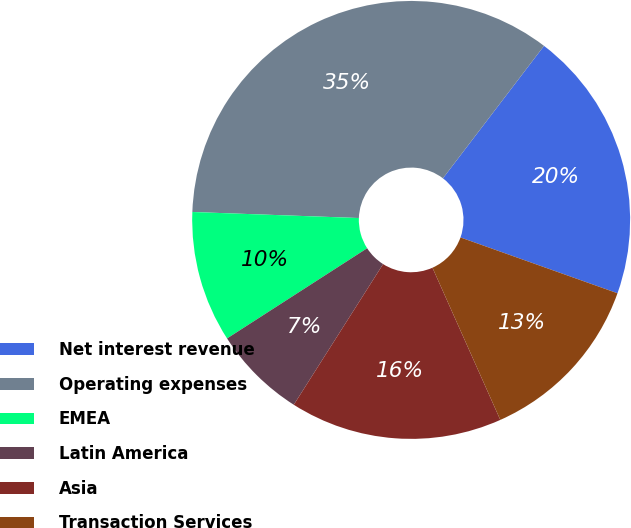Convert chart to OTSL. <chart><loc_0><loc_0><loc_500><loc_500><pie_chart><fcel>Net interest revenue<fcel>Operating expenses<fcel>EMEA<fcel>Latin America<fcel>Asia<fcel>Transaction Services<nl><fcel>20.06%<fcel>34.8%<fcel>9.68%<fcel>6.89%<fcel>15.68%<fcel>12.89%<nl></chart> 